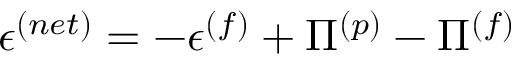Convert formula to latex. <formula><loc_0><loc_0><loc_500><loc_500>\epsilon ^ { ( n e t ) } = - \epsilon ^ { ( f ) } + \Pi ^ { ( p ) } - \Pi ^ { ( f ) }</formula> 